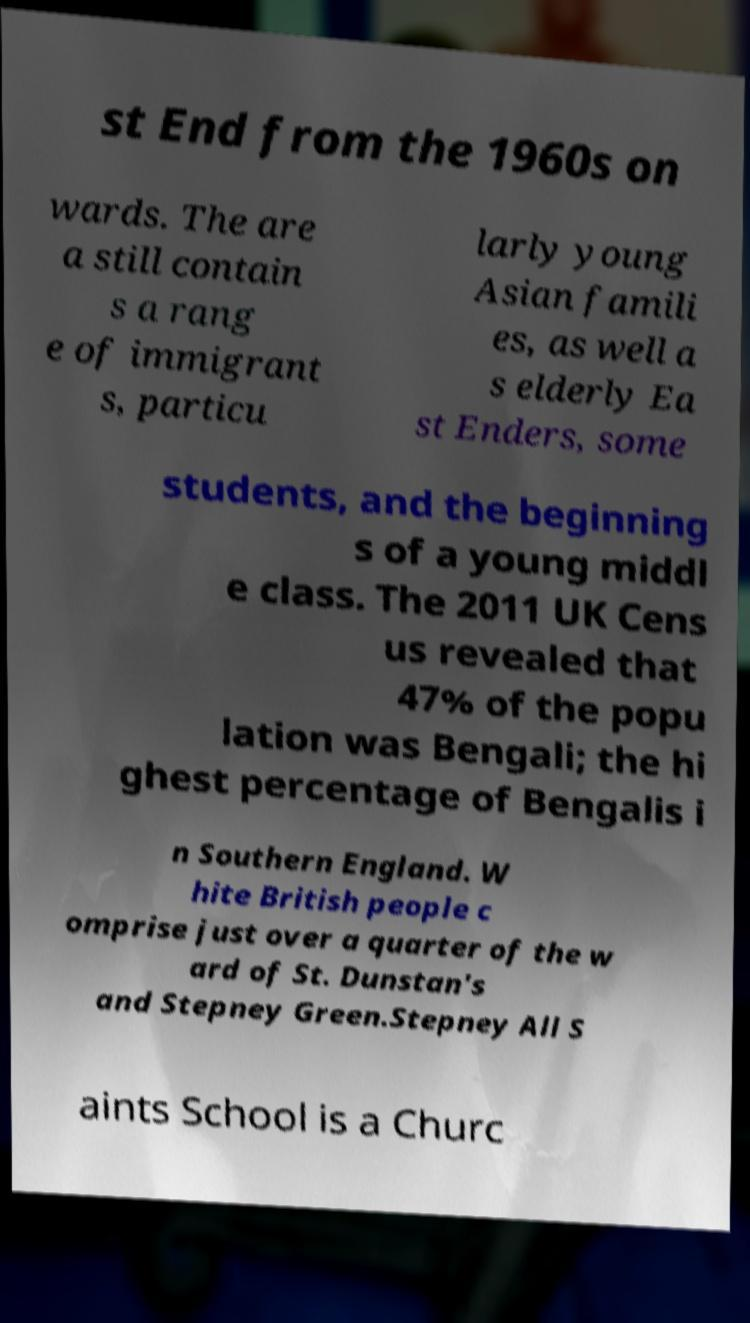Can you accurately transcribe the text from the provided image for me? st End from the 1960s on wards. The are a still contain s a rang e of immigrant s, particu larly young Asian famili es, as well a s elderly Ea st Enders, some students, and the beginning s of a young middl e class. The 2011 UK Cens us revealed that 47% of the popu lation was Bengali; the hi ghest percentage of Bengalis i n Southern England. W hite British people c omprise just over a quarter of the w ard of St. Dunstan's and Stepney Green.Stepney All S aints School is a Churc 